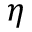<formula> <loc_0><loc_0><loc_500><loc_500>\eta</formula> 